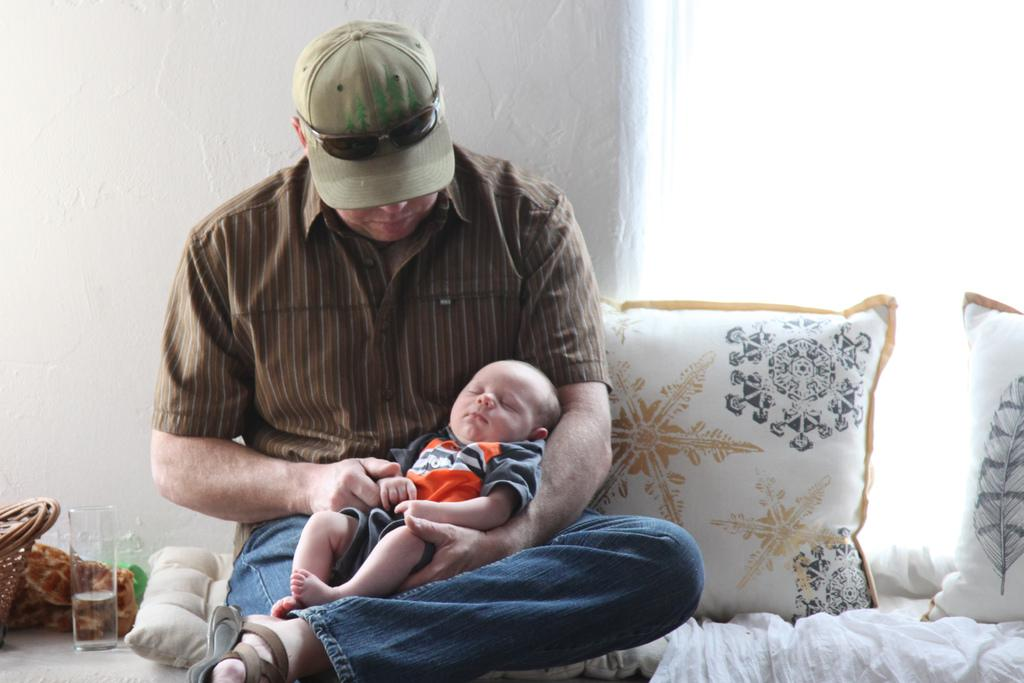What is the man in the image doing? The man is sitting and holding a baby in the image. What is the man wearing on his head? The man is wearing a cap in the image. How many pillows are visible in the image? There are two pillows in the image. What is the material used for the baby's comfort in the image? There is a cloth in the image that might be used for the baby's comfort. What is the background of the image? There is a wall in the background of the image. What object can be used for drinking in the image? There is a glass in the image that can be used for drinking. How many feathers are present in the image? There are no feathers visible in the image. What type of art is displayed on the wall in the image? There is no art displayed on the wall in the image; it is just a plain wall. 